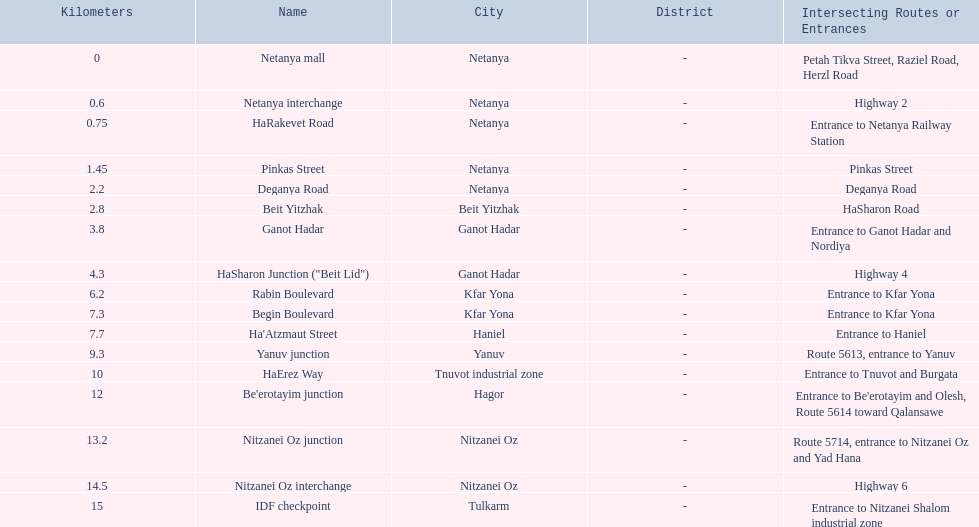What are all the names? Netanya mall, Netanya interchange, HaRakevet Road, Pinkas Street, Deganya Road, Beit Yitzhak, Ganot Hadar, HaSharon Junction ("Beit Lid"), Rabin Boulevard, Begin Boulevard, Ha'Atzmaut Street, Yanuv junction, HaErez Way, Be'erotayim junction, Nitzanei Oz junction, Nitzanei Oz interchange, IDF checkpoint. Where do they intersect? Petah Tikva Street, Raziel Road, Herzl Road, Highway 2, Entrance to Netanya Railway Station, Pinkas Street, Deganya Road, HaSharon Road, Entrance to Ganot Hadar and Nordiya, Highway 4, Entrance to Kfar Yona, Entrance to Kfar Yona, Entrance to Haniel, Route 5613, entrance to Yanuv, Entrance to Tnuvot and Burgata, Entrance to Be'erotayim and Olesh,\nRoute 5614 toward Qalansawe, Route 5714, entrance to Nitzanei Oz and Yad Hana, Highway 6, Entrance to Nitzanei Shalom industrial zone. And which shares an intersection with rabin boulevard? Begin Boulevard. 